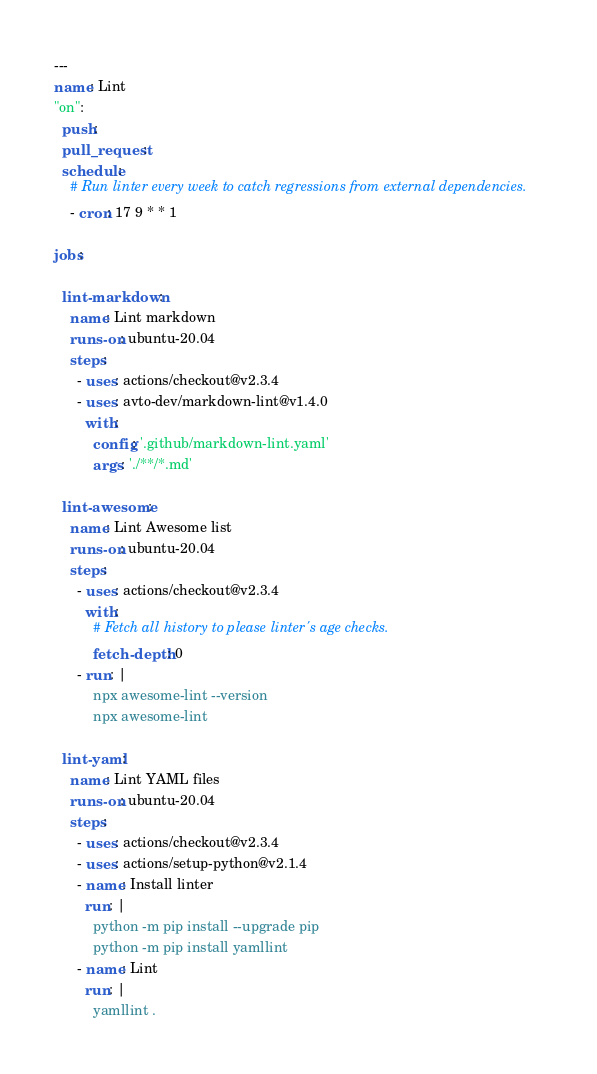Convert code to text. <code><loc_0><loc_0><loc_500><loc_500><_YAML_>---
name: Lint
"on":
  push:
  pull_request:
  schedule:
    # Run linter every week to catch regressions from external dependencies.
    - cron: 17 9 * * 1

jobs:

  lint-markdown:
    name: Lint markdown
    runs-on: ubuntu-20.04
    steps:
      - uses: actions/checkout@v2.3.4
      - uses: avto-dev/markdown-lint@v1.4.0
        with:
          config: '.github/markdown-lint.yaml'
          args: './**/*.md'

  lint-awesome:
    name: Lint Awesome list
    runs-on: ubuntu-20.04
    steps:
      - uses: actions/checkout@v2.3.4
        with:
          # Fetch all history to please linter's age checks.
          fetch-depth: 0
      - run: |
          npx awesome-lint --version
          npx awesome-lint

  lint-yaml:
    name: Lint YAML files
    runs-on: ubuntu-20.04
    steps:
      - uses: actions/checkout@v2.3.4
      - uses: actions/setup-python@v2.1.4
      - name: Install linter
        run: |
          python -m pip install --upgrade pip
          python -m pip install yamllint
      - name: Lint
        run: |
          yamllint .
</code> 